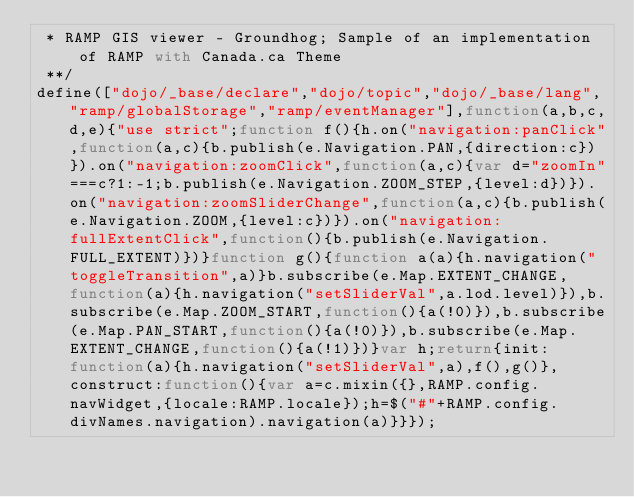<code> <loc_0><loc_0><loc_500><loc_500><_JavaScript_> * RAMP GIS viewer - Groundhog; Sample of an implementation of RAMP with Canada.ca Theme 
 **/
define(["dojo/_base/declare","dojo/topic","dojo/_base/lang","ramp/globalStorage","ramp/eventManager"],function(a,b,c,d,e){"use strict";function f(){h.on("navigation:panClick",function(a,c){b.publish(e.Navigation.PAN,{direction:c})}).on("navigation:zoomClick",function(a,c){var d="zoomIn"===c?1:-1;b.publish(e.Navigation.ZOOM_STEP,{level:d})}).on("navigation:zoomSliderChange",function(a,c){b.publish(e.Navigation.ZOOM,{level:c})}).on("navigation:fullExtentClick",function(){b.publish(e.Navigation.FULL_EXTENT)})}function g(){function a(a){h.navigation("toggleTransition",a)}b.subscribe(e.Map.EXTENT_CHANGE,function(a){h.navigation("setSliderVal",a.lod.level)}),b.subscribe(e.Map.ZOOM_START,function(){a(!0)}),b.subscribe(e.Map.PAN_START,function(){a(!0)}),b.subscribe(e.Map.EXTENT_CHANGE,function(){a(!1)})}var h;return{init:function(a){h.navigation("setSliderVal",a),f(),g()},construct:function(){var a=c.mixin({},RAMP.config.navWidget,{locale:RAMP.locale});h=$("#"+RAMP.config.divNames.navigation).navigation(a)}}});</code> 